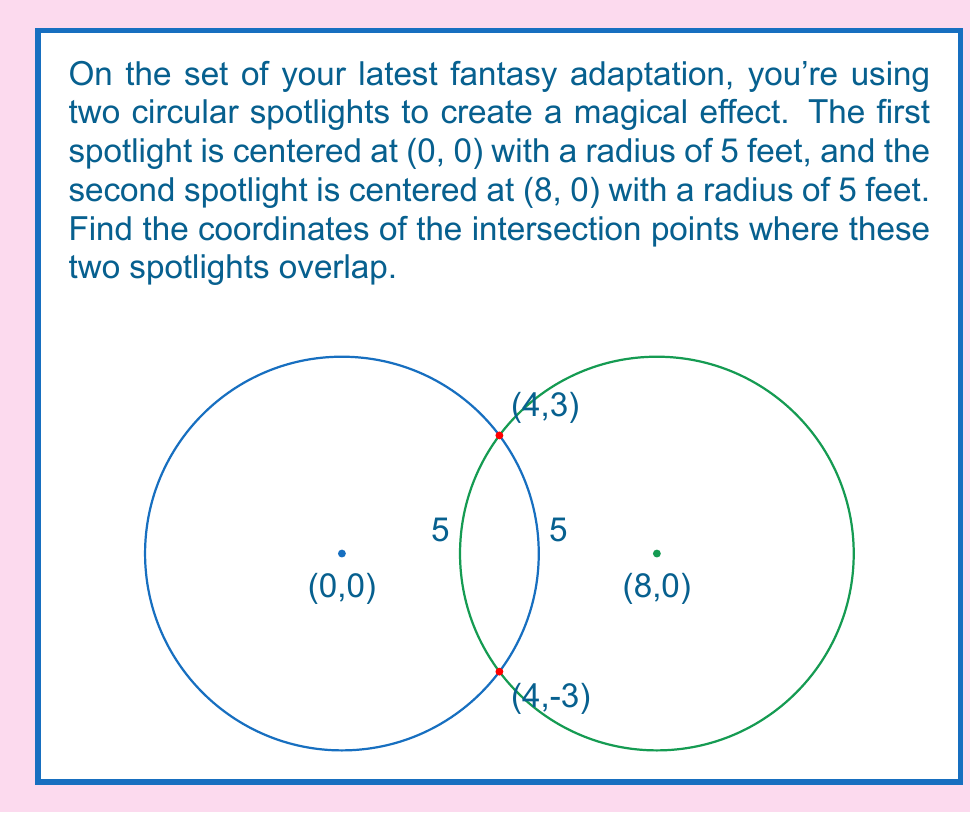Give your solution to this math problem. Let's approach this step-by-step:

1) The equations of the two circles are:

   Circle 1: $x^2 + y^2 = 25$
   Circle 2: $(x-8)^2 + y^2 = 25$

2) To find the intersection points, we need to solve these equations simultaneously.

3) Subtracting the first equation from the second:

   $(x-8)^2 + y^2 = x^2 + y^2$
   $x^2 - 16x + 64 = x^2$
   $-16x + 64 = 0$
   $-16x = -64$
   $x = 4$

4) Now that we know the x-coordinate of the intersection points, we can substitute this back into either of the original equations. Let's use the first one:

   $4^2 + y^2 = 25$
   $16 + y^2 = 25$
   $y^2 = 9$
   $y = \pm 3$

5) Therefore, the intersection points are (4, 3) and (4, -3).

6) We can verify this by substituting these points into both original equations:

   For (4, 3): $4^2 + 3^2 = 25$ and $(4-8)^2 + 3^2 = 25$
   For (4, -3): $4^2 + (-3)^2 = 25$ and $(4-8)^2 + (-3)^2 = 25$

   Both points satisfy both equations.
Answer: (4, 3) and (4, -3) 